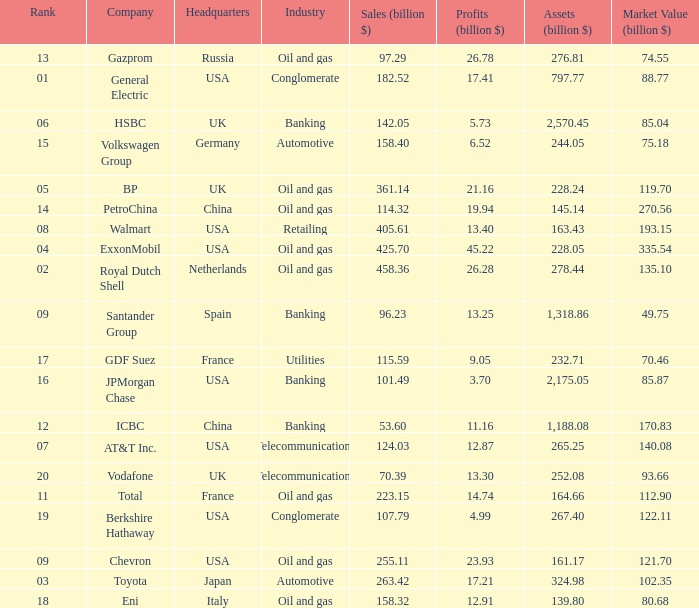Name the lowest Market Value (billion $) which has Assets (billion $) larger than 276.81, and a Company of toyota, and Profits (billion $) larger than 17.21? None. 